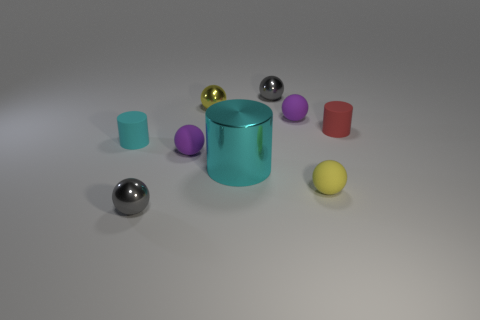What is the shape of the small yellow object that is made of the same material as the red object? The small yellow object shares its spherical shape with the small shiny red sphere positioned towards the right. 